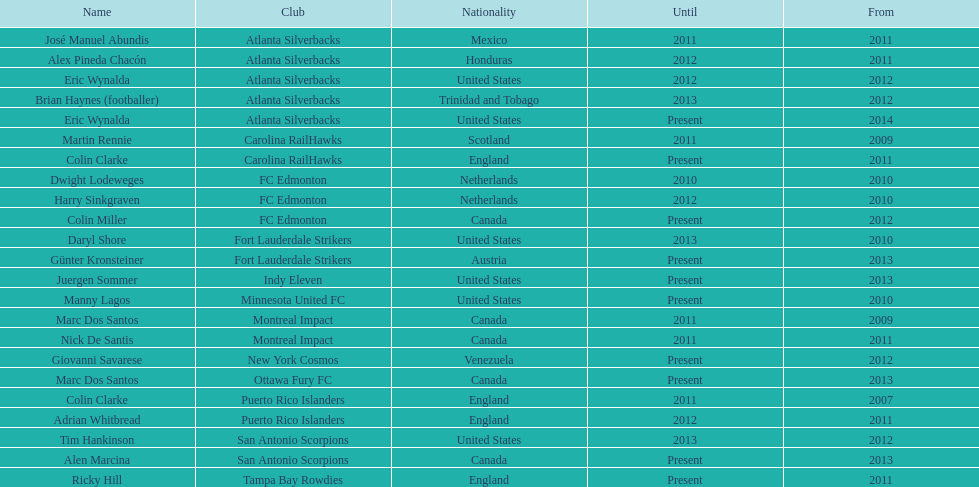How long did colin clarke coach the puerto rico islanders for? 4 years. 